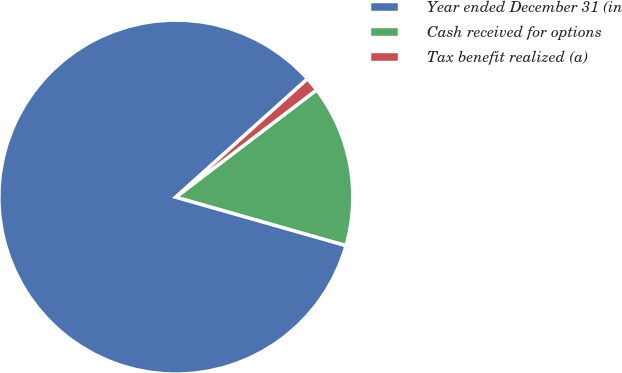Convert chart. <chart><loc_0><loc_0><loc_500><loc_500><pie_chart><fcel>Year ended December 31 (in<fcel>Cash received for options<fcel>Tax benefit realized (a)<nl><fcel>83.93%<fcel>14.77%<fcel>1.29%<nl></chart> 